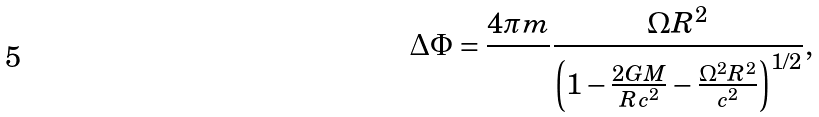Convert formula to latex. <formula><loc_0><loc_0><loc_500><loc_500>\Delta \Phi = \frac { 4 \pi m } { } \frac { \Omega R ^ { 2 } } { \left ( 1 - \frac { 2 G M } { R c ^ { 2 } } - \frac { \Omega ^ { 2 } R ^ { 2 } } { c ^ { 2 } } \right ) ^ { 1 / 2 } } ,</formula> 